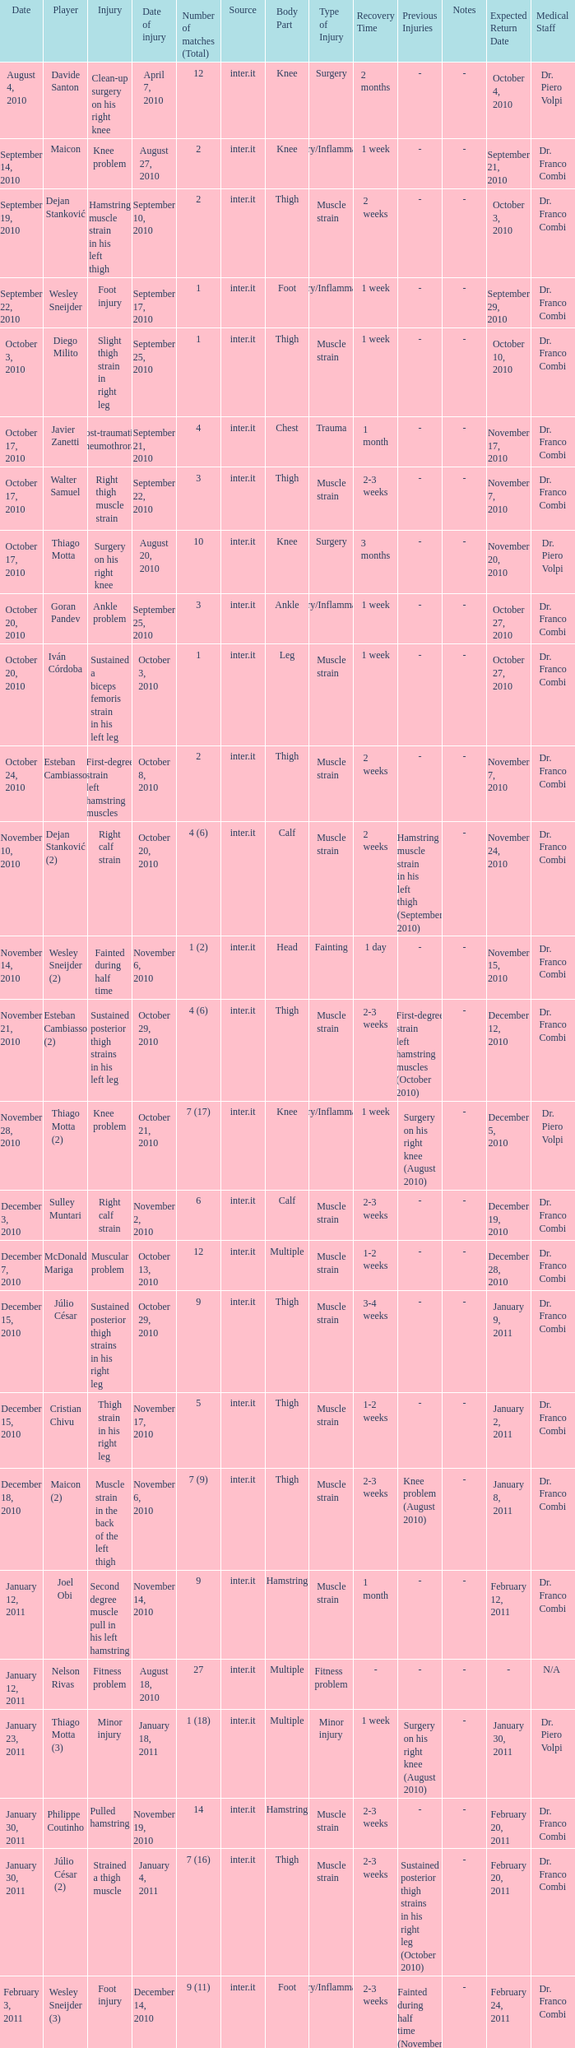What is the date of injury when the injury is foot injury and the number of matches (total) is 1? September 17, 2010. 